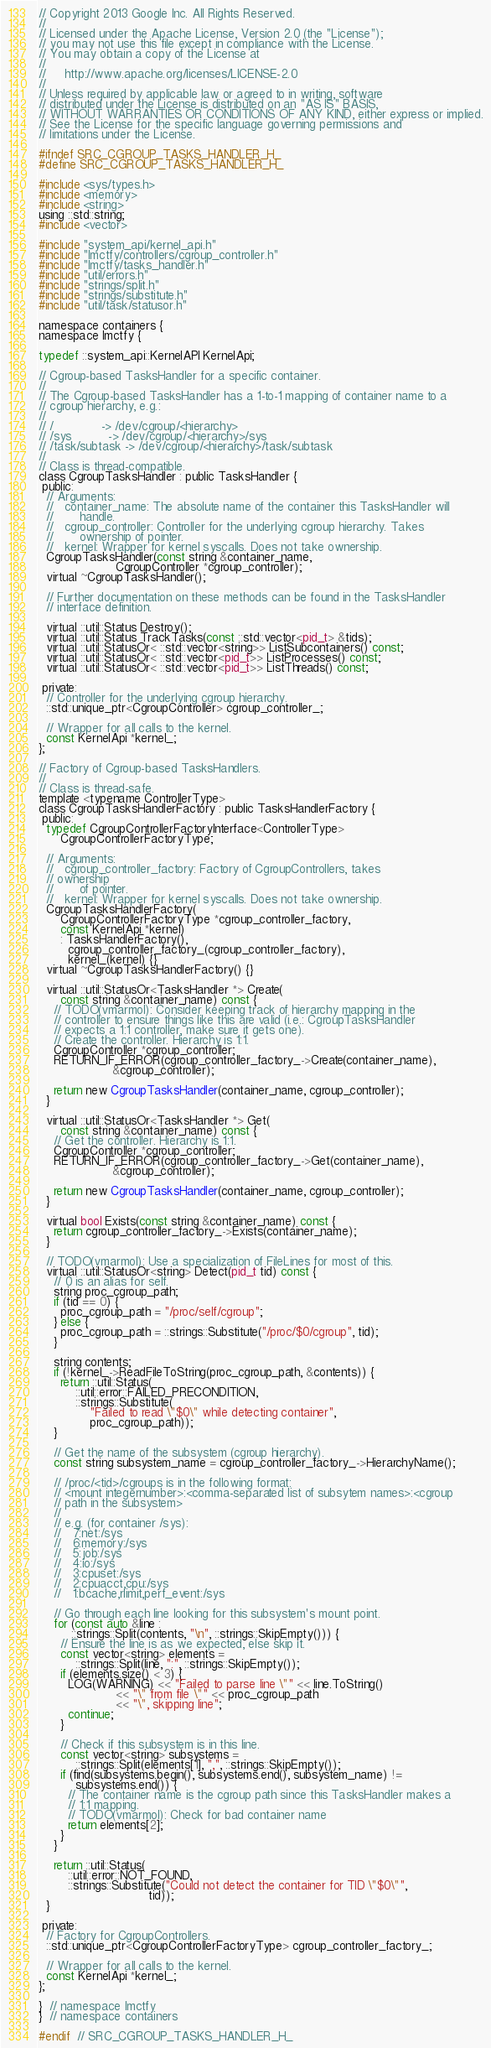Convert code to text. <code><loc_0><loc_0><loc_500><loc_500><_C_>// Copyright 2013 Google Inc. All Rights Reserved.
//
// Licensed under the Apache License, Version 2.0 (the "License");
// you may not use this file except in compliance with the License.
// You may obtain a copy of the License at
//
//     http://www.apache.org/licenses/LICENSE-2.0
//
// Unless required by applicable law or agreed to in writing, software
// distributed under the License is distributed on an "AS IS" BASIS,
// WITHOUT WARRANTIES OR CONDITIONS OF ANY KIND, either express or implied.
// See the License for the specific language governing permissions and
// limitations under the License.

#ifndef SRC_CGROUP_TASKS_HANDLER_H_
#define SRC_CGROUP_TASKS_HANDLER_H_

#include <sys/types.h>
#include <memory>
#include <string>
using ::std::string;
#include <vector>

#include "system_api/kernel_api.h"
#include "lmctfy/controllers/cgroup_controller.h"
#include "lmctfy/tasks_handler.h"
#include "util/errors.h"
#include "strings/split.h"
#include "strings/substitute.h"
#include "util/task/statusor.h"

namespace containers {
namespace lmctfy {

typedef ::system_api::KernelAPI KernelApi;

// Cgroup-based TasksHandler for a specific container.
//
// The Cgroup-based TasksHandler has a 1-to-1 mapping of container name to a
// cgroup hierarchy, e.g.:
//
// /             -> /dev/cgroup/<hierarchy>
// /sys          -> /dev/cgroup/<hierarchy>/sys
// /task/subtask -> /dev/cgroup/<hierarchy>/task/subtask
//
// Class is thread-compatible.
class CgroupTasksHandler : public TasksHandler {
 public:
  // Arguments:
  //   container_name: The absolute name of the container this TasksHandler will
  //       handle.
  //   cgroup_controller: Controller for the underlying cgroup hierarchy. Takes
  //       ownership of pointer.
  //   kernel: Wrapper for kernel syscalls. Does not take ownership.
  CgroupTasksHandler(const string &container_name,
                     CgroupController *cgroup_controller);
  virtual ~CgroupTasksHandler();

  // Further documentation on these methods can be found in the TasksHandler
  // interface definition.

  virtual ::util::Status Destroy();
  virtual ::util::Status TrackTasks(const ::std::vector<pid_t> &tids);
  virtual ::util::StatusOr< ::std::vector<string>> ListSubcontainers() const;
  virtual ::util::StatusOr< ::std::vector<pid_t>> ListProcesses() const;
  virtual ::util::StatusOr< ::std::vector<pid_t>> ListThreads() const;

 private:
  // Controller for the underlying cgroup hierarchy.
  ::std::unique_ptr<CgroupController> cgroup_controller_;

  // Wrapper for all calls to the kernel.
  const KernelApi *kernel_;
};

// Factory of Cgroup-based TasksHandlers.
//
// Class is thread-safe.
template <typename ControllerType>
class CgroupTasksHandlerFactory : public TasksHandlerFactory {
 public:
  typedef CgroupControllerFactoryInterface<ControllerType>
      CgroupControllerFactoryType;

  // Arguments:
  //   cgroup_controller_factory: Factory of CgroupControllers, takes
  // ownership
  //       of pointer.
  //   kernel: Wrapper for kernel syscalls. Does not take ownership.
  CgroupTasksHandlerFactory(
      CgroupControllerFactoryType *cgroup_controller_factory,
      const KernelApi *kernel)
      : TasksHandlerFactory(),
        cgroup_controller_factory_(cgroup_controller_factory),
        kernel_(kernel) {}
  virtual ~CgroupTasksHandlerFactory() {}

  virtual ::util::StatusOr<TasksHandler *> Create(
      const string &container_name) const {
    // TODO(vmarmol): Consider keeping track of hierarchy mapping in the
    // controller to ensure things like this are valid (i.e.: CgroupTasksHandler
    // expects a 1:1 controller, make sure it gets one).
    // Create the controller. Hierarchy is 1:1.
    CgroupController *cgroup_controller;
    RETURN_IF_ERROR(cgroup_controller_factory_->Create(container_name),
                    &cgroup_controller);

    return new CgroupTasksHandler(container_name, cgroup_controller);
  }

  virtual ::util::StatusOr<TasksHandler *> Get(
      const string &container_name) const {
    // Get the controller. Hierarchy is 1:1.
    CgroupController *cgroup_controller;
    RETURN_IF_ERROR(cgroup_controller_factory_->Get(container_name),
                    &cgroup_controller);

    return new CgroupTasksHandler(container_name, cgroup_controller);
  }

  virtual bool Exists(const string &container_name) const {
    return cgroup_controller_factory_->Exists(container_name);
  }

  // TODO(vmarmol): Use a specialization of FileLines for most of this.
  virtual ::util::StatusOr<string> Detect(pid_t tid) const {
    // 0 is an alias for self.
    string proc_cgroup_path;
    if (tid == 0) {
      proc_cgroup_path = "/proc/self/cgroup";
    } else {
      proc_cgroup_path = ::strings::Substitute("/proc/$0/cgroup", tid);
    }

    string contents;
    if (!kernel_->ReadFileToString(proc_cgroup_path, &contents)) {
      return ::util::Status(
          ::util::error::FAILED_PRECONDITION,
          ::strings::Substitute(
              "Failed to read \"$0\" while detecting container",
              proc_cgroup_path));
    }

    // Get the name of the subsystem (cgroup hierarchy).
    const string subsystem_name = cgroup_controller_factory_->HierarchyName();

    // /proc/<tid>/cgroups is in the following format:
    // <mount integernumber>:<comma-separated list of subsytem names>:<cgroup
    // path in the subsystem>
    //
    // e.g. (for container /sys):
    //   7:net:/sys
    //   6:memory:/sys
    //   5:job:/sys
    //   4:io:/sys
    //   3:cpuset:/sys
    //   2:cpuacct,cpu:/sys
    //   1:bcache,rlimit,perf_event:/sys

    // Go through each line looking for this subsystem's mount point.
    for (const auto &line :
         ::strings::Split(contents, "\n", ::strings::SkipEmpty())) {
      // Ensure the line is as we expected, else skip it.
      const vector<string> elements =
          ::strings::Split(line, ":", ::strings::SkipEmpty());
      if (elements.size() < 3) {
        LOG(WARNING) << "Failed to parse line \"" << line.ToString()
                     << "\" from file \"" << proc_cgroup_path
                     << "\", skipping line";
        continue;
      }

      // Check if this subsystem is in this line.
      const vector<string> subsystems =
          ::strings::Split(elements[1], ",", ::strings::SkipEmpty());
      if (find(subsystems.begin(), subsystems.end(), subsystem_name) !=
          subsystems.end()) {
        // The container name is the cgroup path since this TasksHandler makes a
        // 1:1 mapping.
        // TODO(vmarmol): Check for bad container name
        return elements[2];
      }
    }

    return ::util::Status(
        ::util::error::NOT_FOUND,
        ::strings::Substitute("Could not detect the container for TID \"$0\"",
                              tid));
  }

 private:
  // Factory for CgroupControllers.
  ::std::unique_ptr<CgroupControllerFactoryType> cgroup_controller_factory_;

  // Wrapper for all calls to the kernel.
  const KernelApi *kernel_;
};

}  // namespace lmctfy
}  // namespace containers

#endif  // SRC_CGROUP_TASKS_HANDLER_H_
</code> 